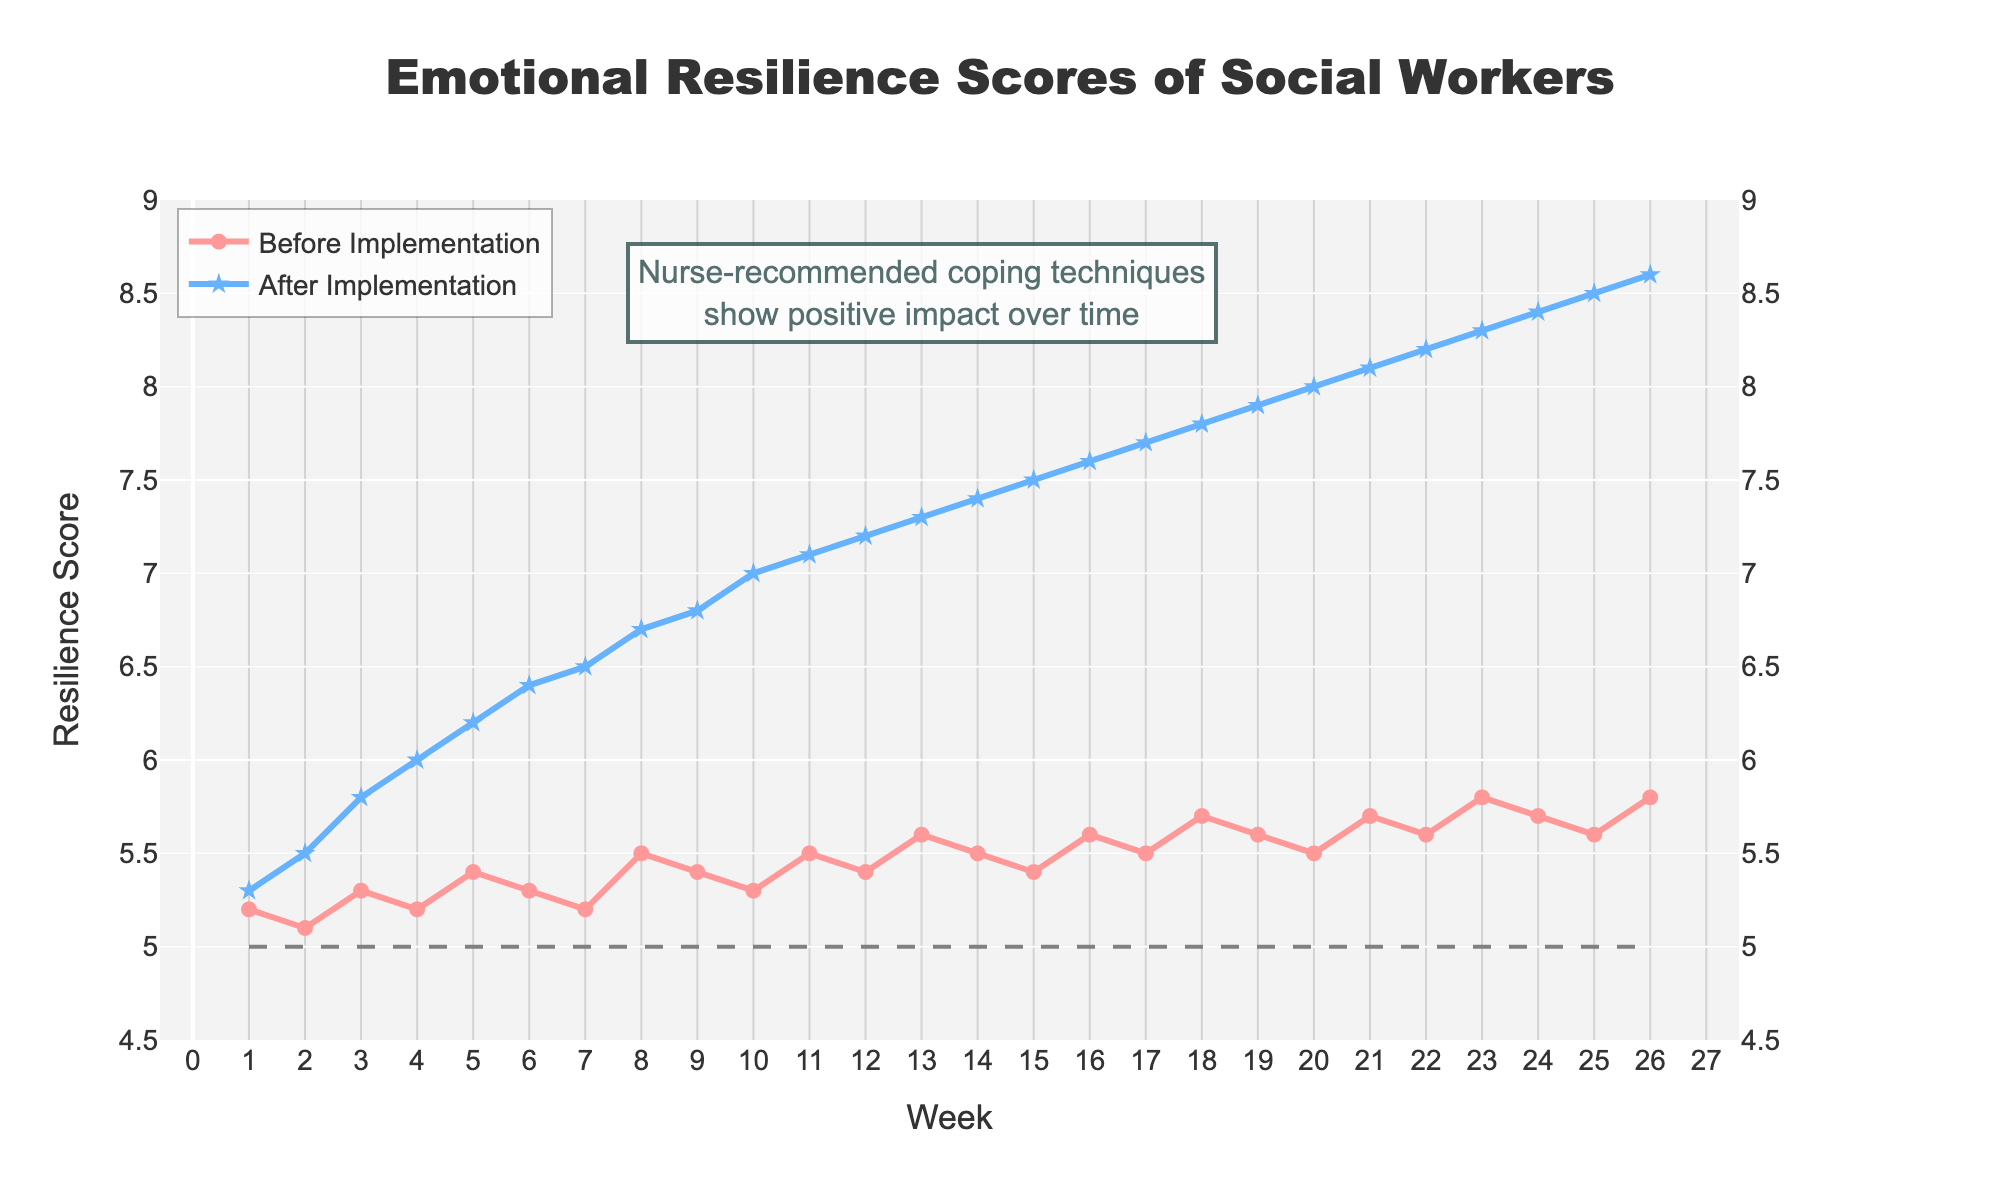What is the emotional resilience score in week 10 before implementing the nurse-recommended coping techniques? The resilience score before implementation for week 10 can be read directly from the chart under the "Before Implementation" curve, marked by a circle.
Answer: 5.3 What is the highest resilience score measured after implementation of the nurse-recommended techniques? Identify the peak value on the "After Implementation" curve, marked using stars, and find the corresponding point.
Answer: 8.6 What is the total increase in the emotional resilience score from week 1 to week 26 after implementing the techniques? Subtract the score at week 1 from the score at week 26 on the "After Implementation" curve. Calculation: 8.6 (week 26) - 5.3 (week 1) = 3.3
Answer: 3.3 At which weeks do the resilience scores intersect the gray dashed baseline? Find the weeks where the scores meet the horizontal gray dashed line (resilience score of 5). Only the "Before Implementation" curve intersects.
Answer: Weeks 1 and 2 Is there a week where the score before implementation is higher than the score after implementation? Compare both curves visually for any occurrences where the "Before Implementation" (marked with circles) score surpasses the "After Implementation" (marked with stars) score.
Answer: No What is the average resilience score before implementation over the 6-month period? Sum all resilience scores before implementation and divide by the number of weeks (26). Calculation: (5.2 + 5.1 + 5.3 + 5.2 + 5.4 + 5.3 + 5.2 + 5.5 + 5.4 + 5.3 + 5.5 + 5.4 + 5.6 + 5.5 + 5.4 + 5.6 + 5.5 + 5.7 + 5.6 + 5.5 + 5.7 + 5.6 + 5.8 + 5.7 + 5.6 + 5.8) / 26 ≈ 5.462
Answer: 5.46 During which weeks does the "After Implementation" score show the steepest increase? Look for the segment of the "After Implementation" curve with the steepest upward slope, indicating the greatest change in short time. This corresponds to weeks 2-4.
Answer: Weeks 2 to 4 What is the difference in resilience scores between weeks 13 and 20 after implementing the techniques? Subtract the score of week 13 from the score of week 20 on the "After Implementation" curve. Calculation: 8.0 (week 20) - 7.3 (week 13) = 0.7
Answer: 0.7 How does the annotation help interpret the data on the plot? The annotation on the plot highlights that nurse-recommended coping techniques have a positive impact over time, emphasizing the overall trend of increasing resilience scores after implementation.
Answer: Indicates positive impact Which week shows the smallest difference in scores before and after implementing the techniques? Identify the week with the smallest vertical gap between the "Before Implementation" and "After Implementation" curves. Week 1 displays the smallest difference.
Answer: Week 1 